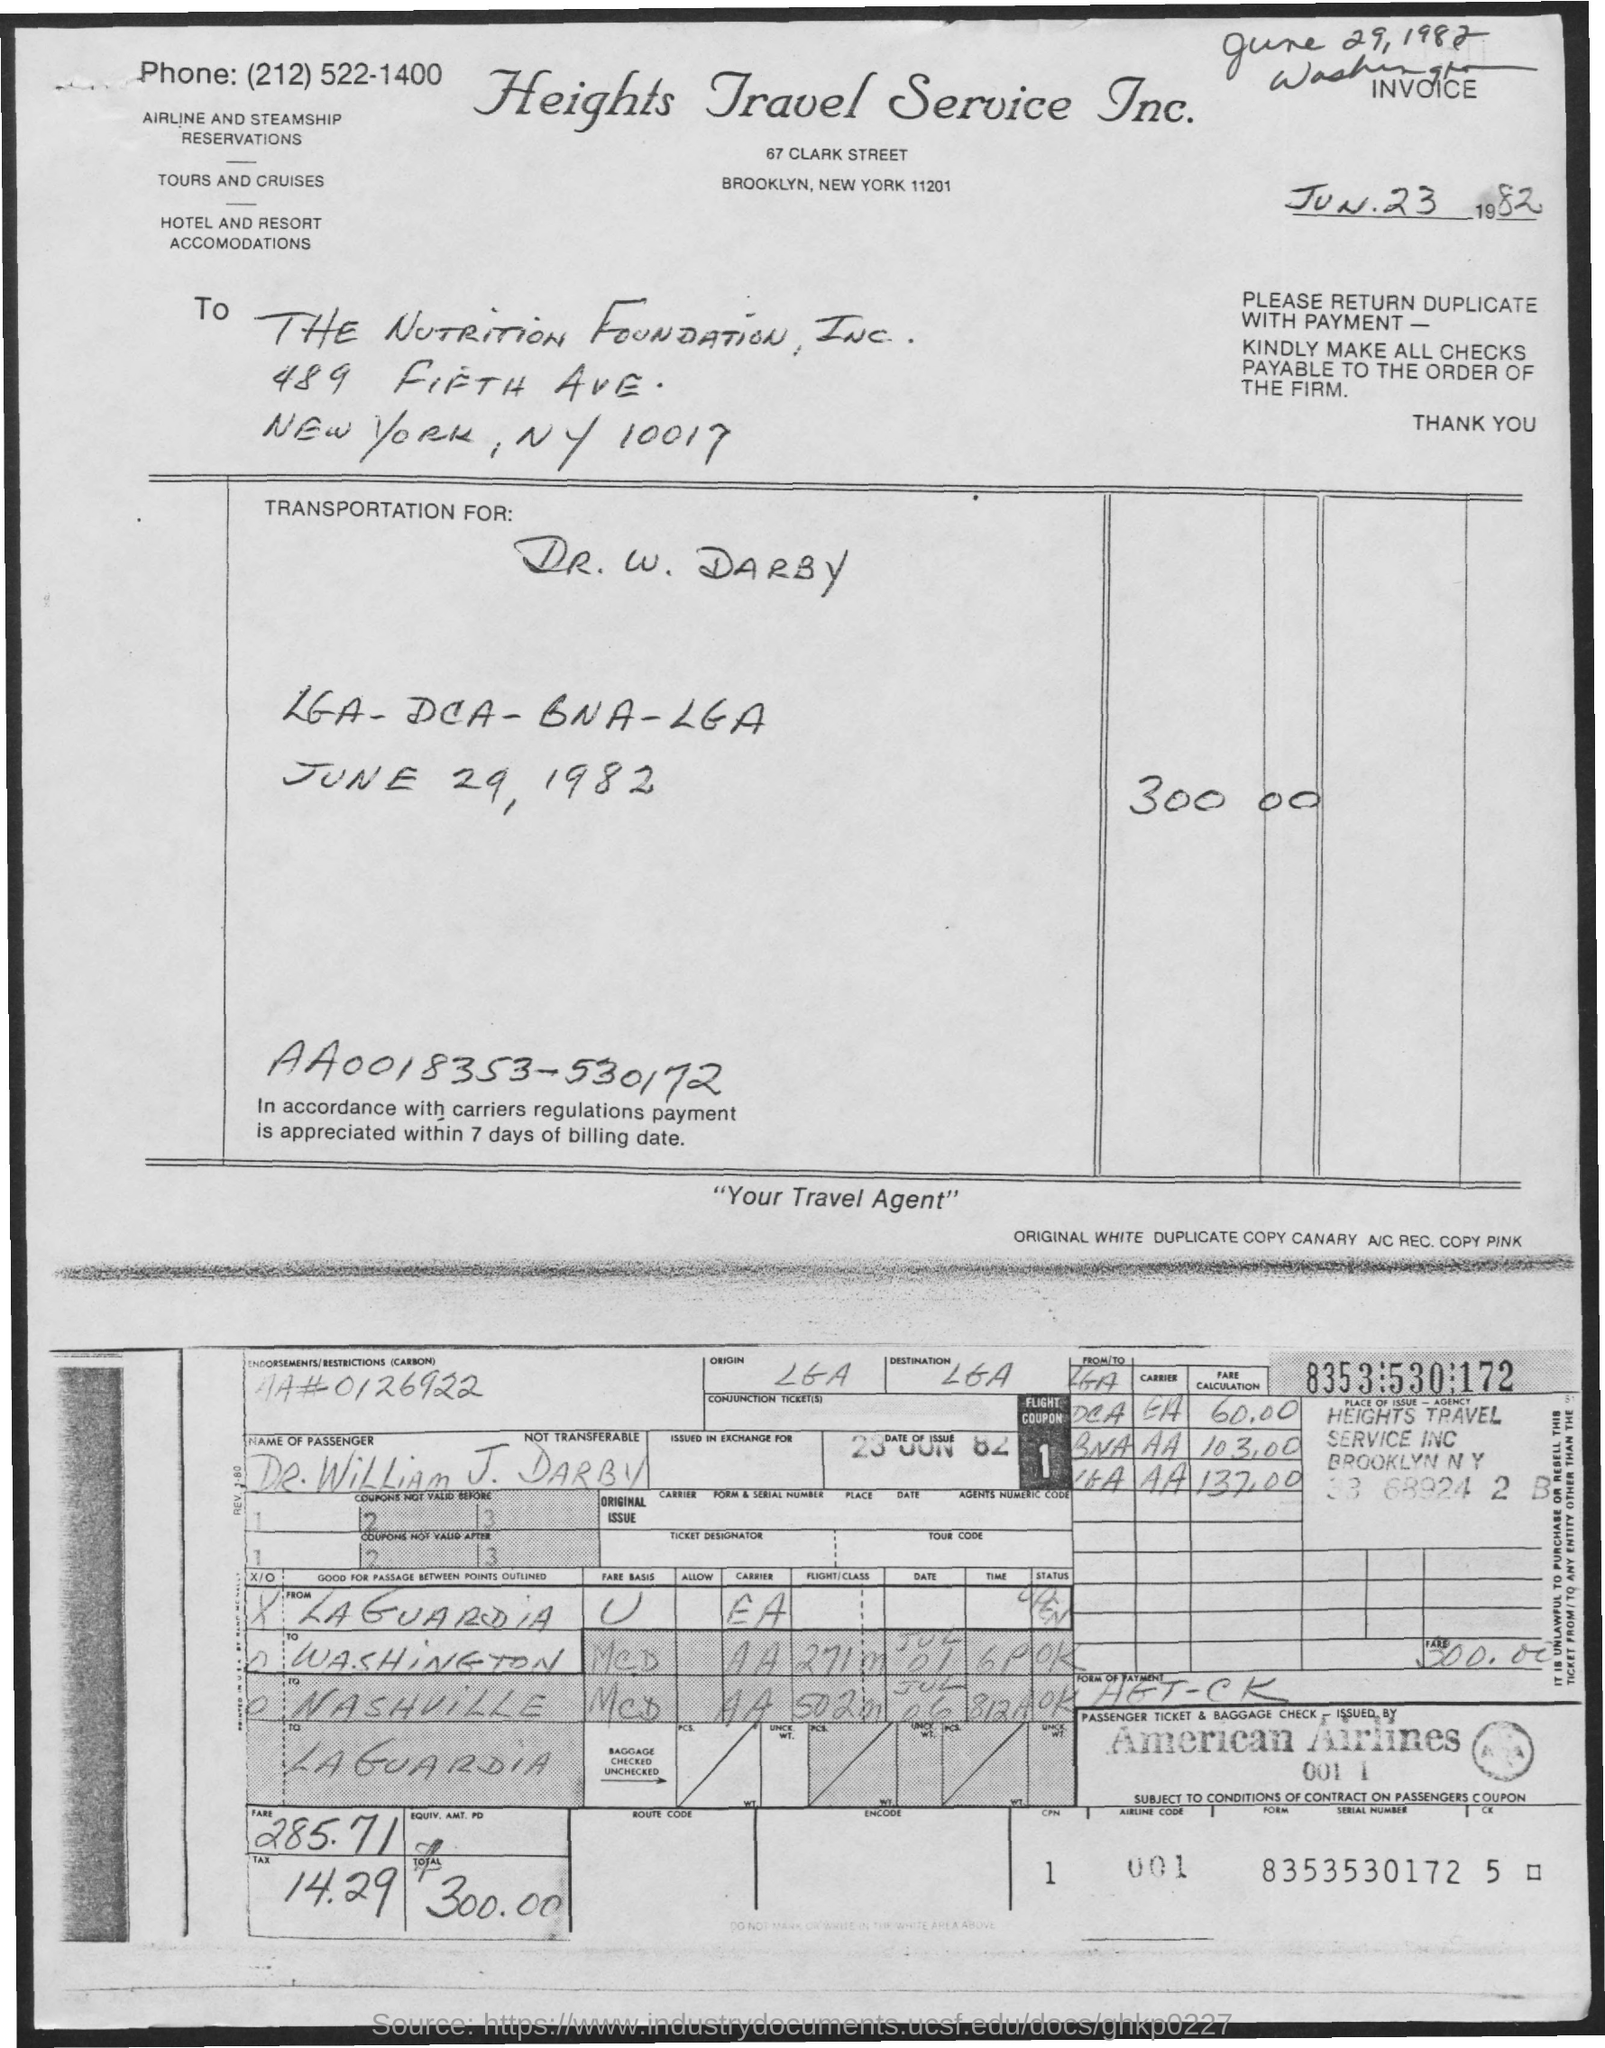How much was the total cost and can you break it down? The total cost for the ticket was $300.00. The base fare was $285.71, and there was an additional charge or tax of $14.29, making up the total amount. 